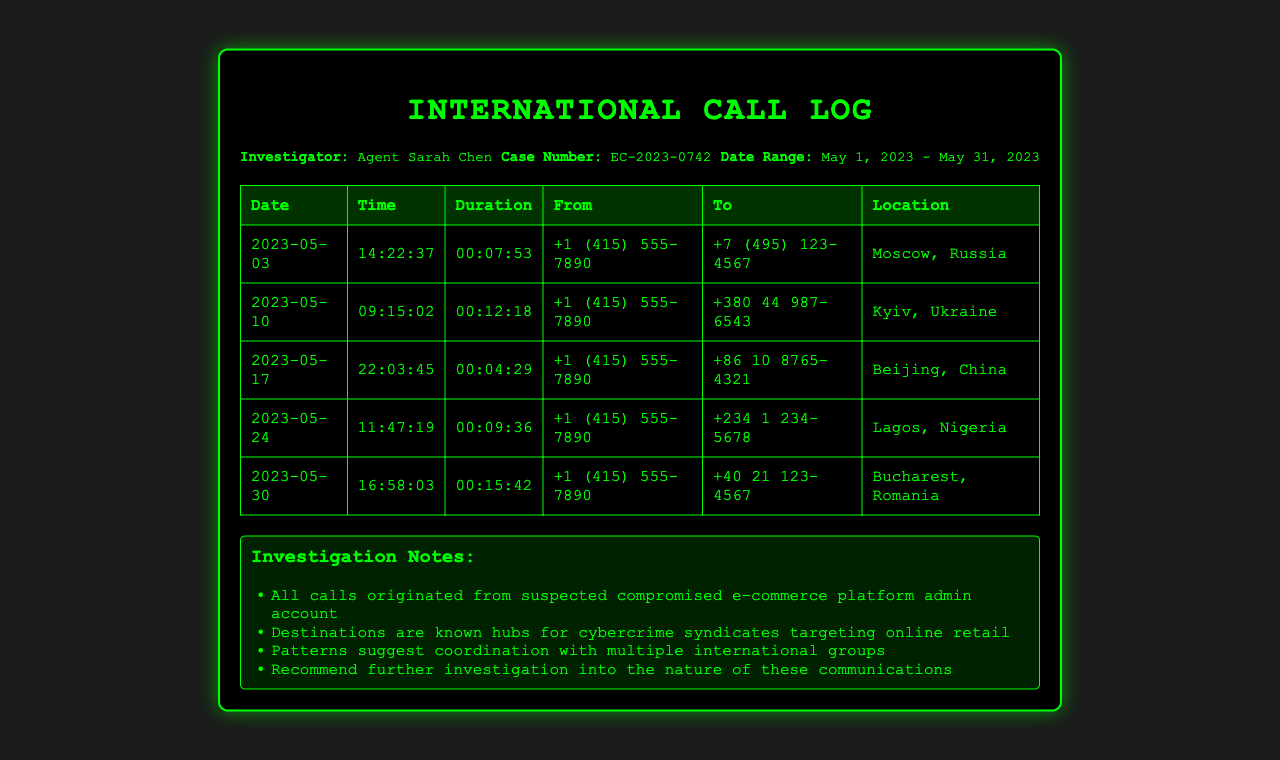What is the case number? The case number is specified in the header info of the document.
Answer: EC-2023-0742 How many calls were made to Moscow, Russia? The table lists each call and its corresponding location, allowing us to count the calls to Moscow.
Answer: 1 What was the duration of the call made on May 10, 2023? The duration column in the table provides the length of the call made on that date.
Answer: 00:12:18 Which country has the phone number +234 1 234-5678? The location for this phone number can be found in the table under the destination column.
Answer: Nigeria What is the investigator's name? The investigator's name is included in the header information section of the document.
Answer: Agent Sarah Chen Which call had the longest duration? The durations in the table can be compared to find the longest one.
Answer: 00:15:42 How many calls were made to countries known for harboring cybercrime syndicates? The notes mention that all call destinations are known hubs for such activities.
Answer: 5 What pattern is suggested by the calls? The notes summarize the findings regarding the nature of calls and their implications.
Answer: Coordination with multiple international groups What date was the last call made? The last entry in the table specifies the date of the most recent call.
Answer: 2023-05-30 